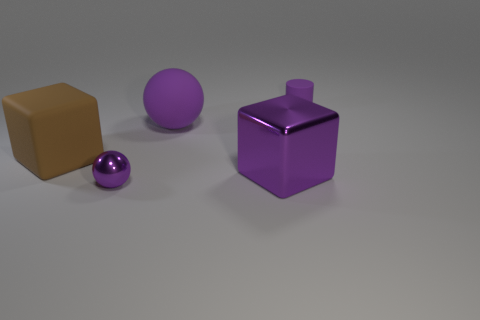Add 2 brown cubes. How many objects exist? 7 Subtract all cubes. How many objects are left? 3 Add 3 tiny cyan rubber cubes. How many tiny cyan rubber cubes exist? 3 Subtract 0 blue cylinders. How many objects are left? 5 Subtract all tiny rubber cylinders. Subtract all cyan shiny objects. How many objects are left? 4 Add 3 small purple shiny things. How many small purple shiny things are left? 4 